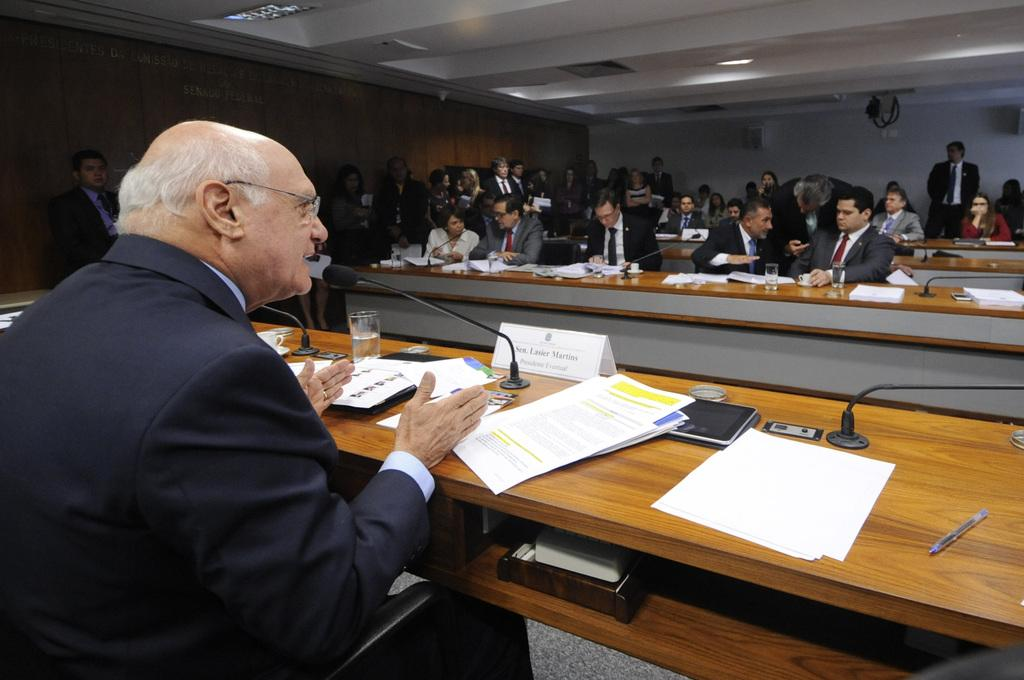How many people are in the image? There is a group of people in the image. What are the people doing in the image? The people are sitting on chairs. Where are the chairs located in relation to the table? The chairs are in front of a table. What can be seen on the table in the image? There is a microphone, pieces of paper, and other objects on the table. What type of gold jewelry is the person wearing in the image? There is no gold jewelry visible in the image. How many marbles are on the table in the image? There are no marbles present in the image. 